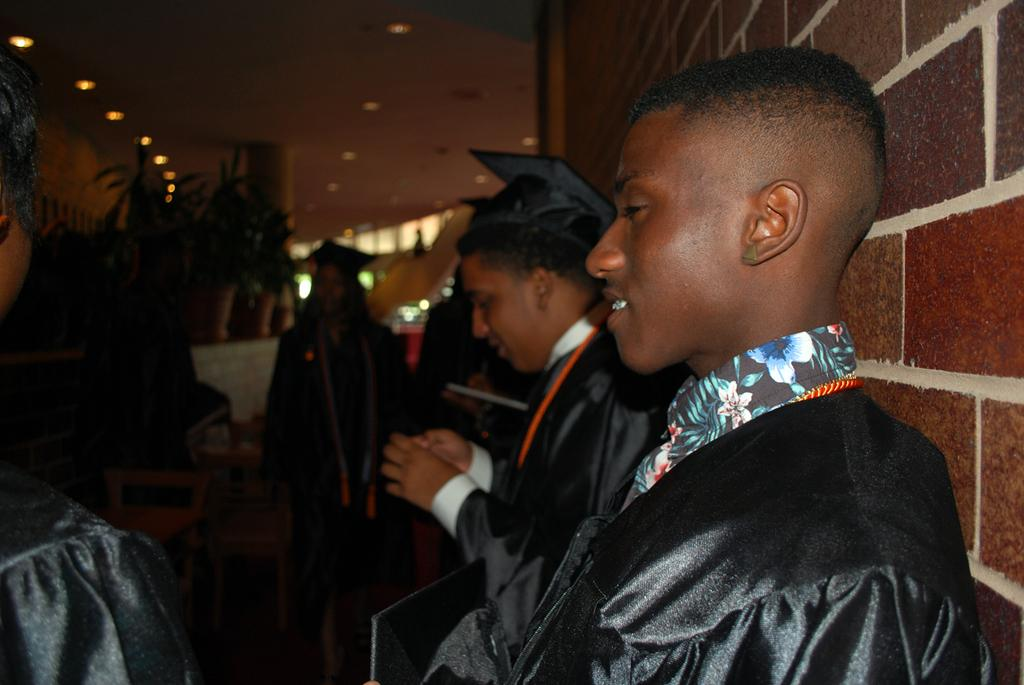What is the main subject of the image? The main subject of the image is a group of people. What can be seen in the background of the image? In the background of the image, there are plants and lights. What type of brain is visible in the image? There is no brain present in the image. Is there a judge in the image? There is no judge present in the image. 